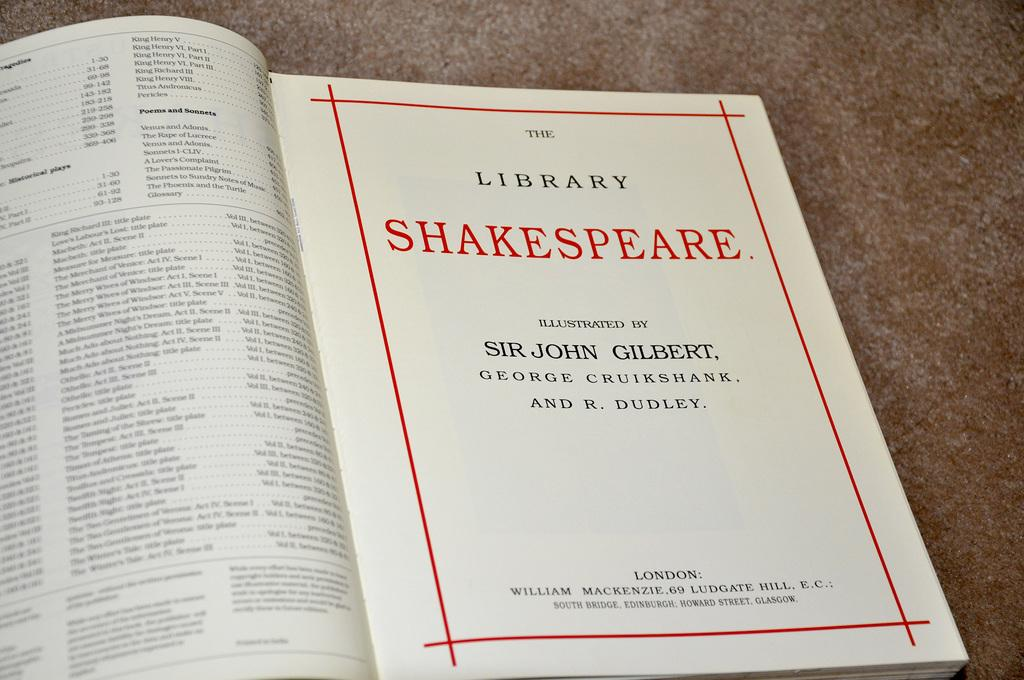<image>
Render a clear and concise summary of the photo. A book open to the title page which says The Library Shakespeare. 